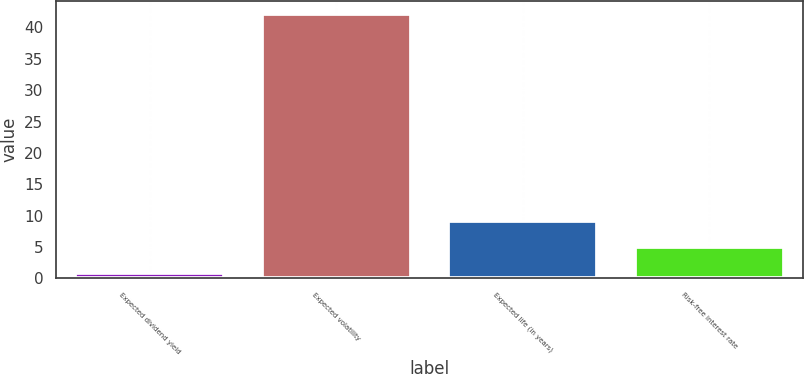Convert chart to OTSL. <chart><loc_0><loc_0><loc_500><loc_500><bar_chart><fcel>Expected dividend yield<fcel>Expected volatility<fcel>Expected life (in years)<fcel>Risk-free interest rate<nl><fcel>0.87<fcel>42.17<fcel>9.13<fcel>5<nl></chart> 